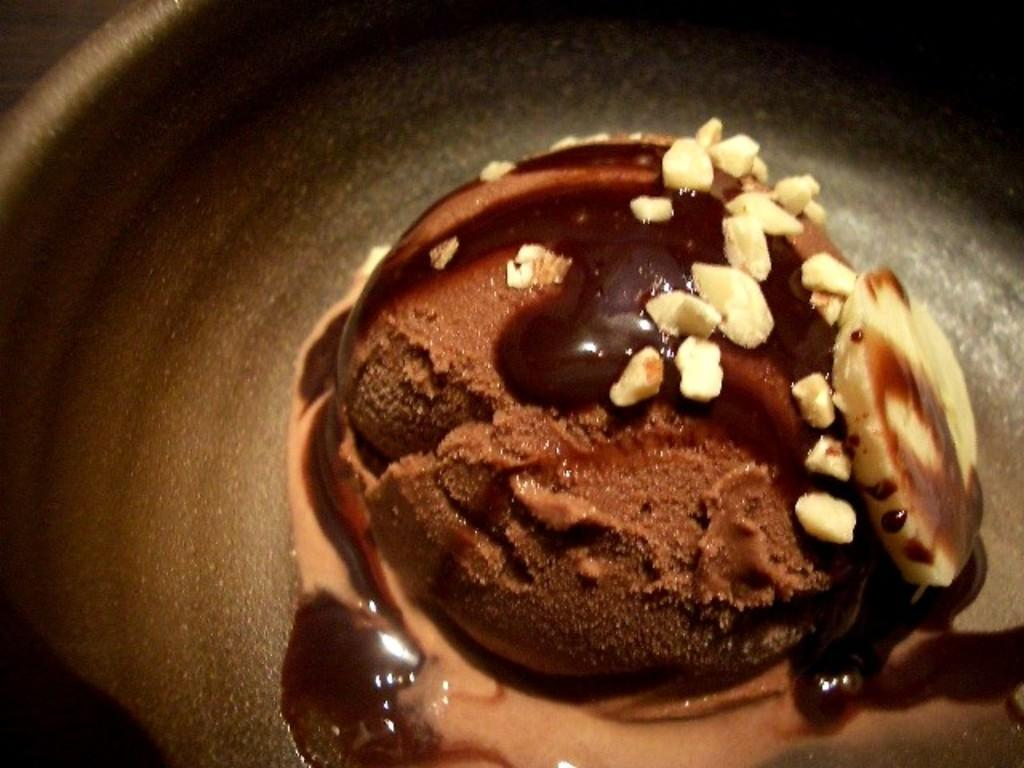What type of dessert is in the image? There is a chocolate dessert in the image. What is the dessert placed on? The dessert is on a black plate. What type of feather can be seen in the image? There is no feather present in the image; it only features a chocolate dessert on a black plate. 